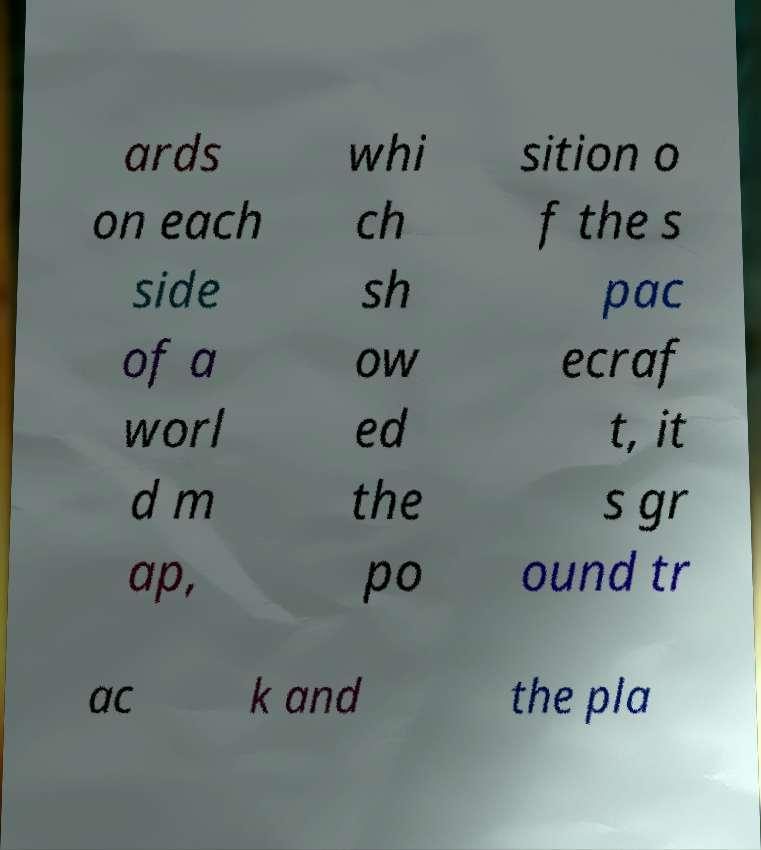Can you accurately transcribe the text from the provided image for me? ards on each side of a worl d m ap, whi ch sh ow ed the po sition o f the s pac ecraf t, it s gr ound tr ac k and the pla 